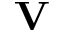<formula> <loc_0><loc_0><loc_500><loc_500>V</formula> 